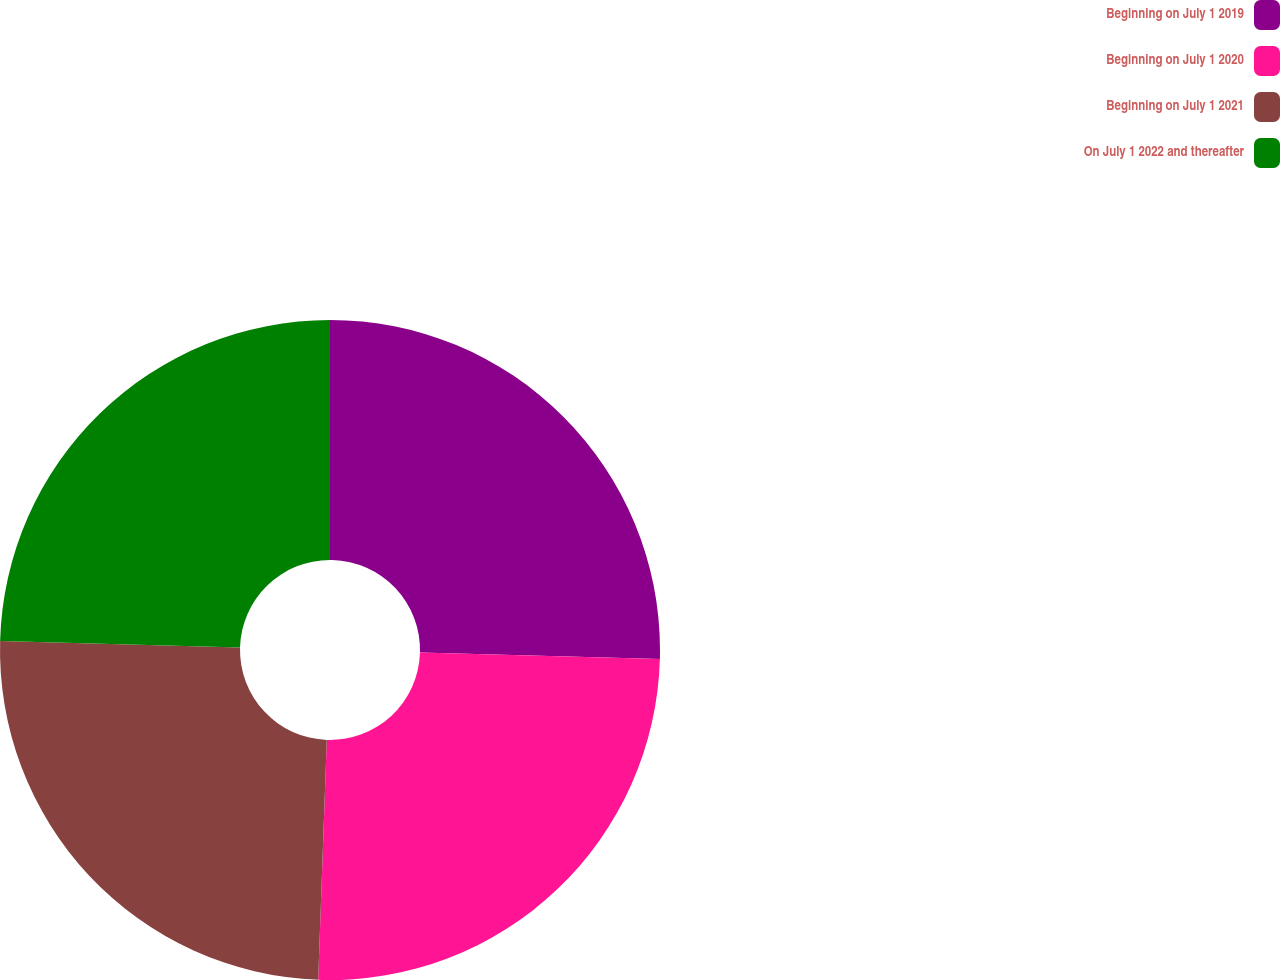Convert chart. <chart><loc_0><loc_0><loc_500><loc_500><pie_chart><fcel>Beginning on July 1 2019<fcel>Beginning on July 1 2020<fcel>Beginning on July 1 2021<fcel>On July 1 2022 and thereafter<nl><fcel>25.43%<fcel>25.14%<fcel>24.86%<fcel>24.57%<nl></chart> 